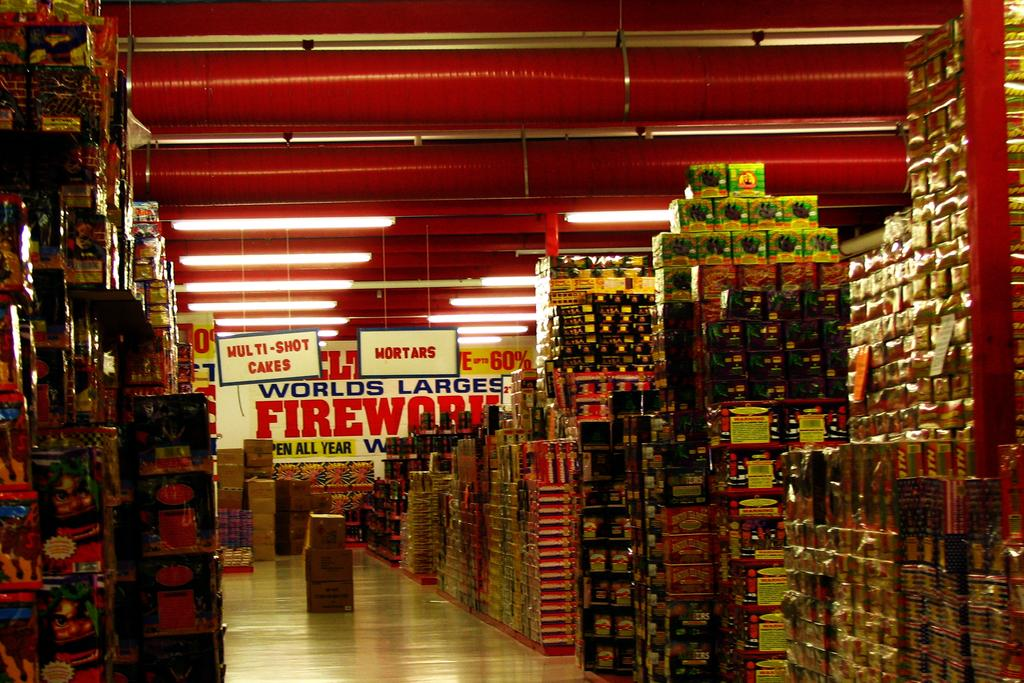Provide a one-sentence caption for the provided image. Store that contains the worlds largest firework and shot cakes. 